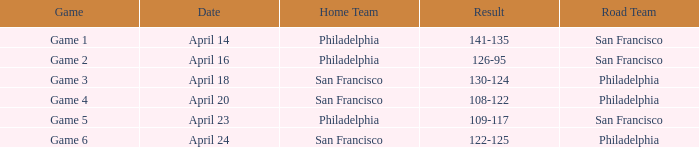Which game had philadelphia as the home side and occurred on april 23? Game 5. 